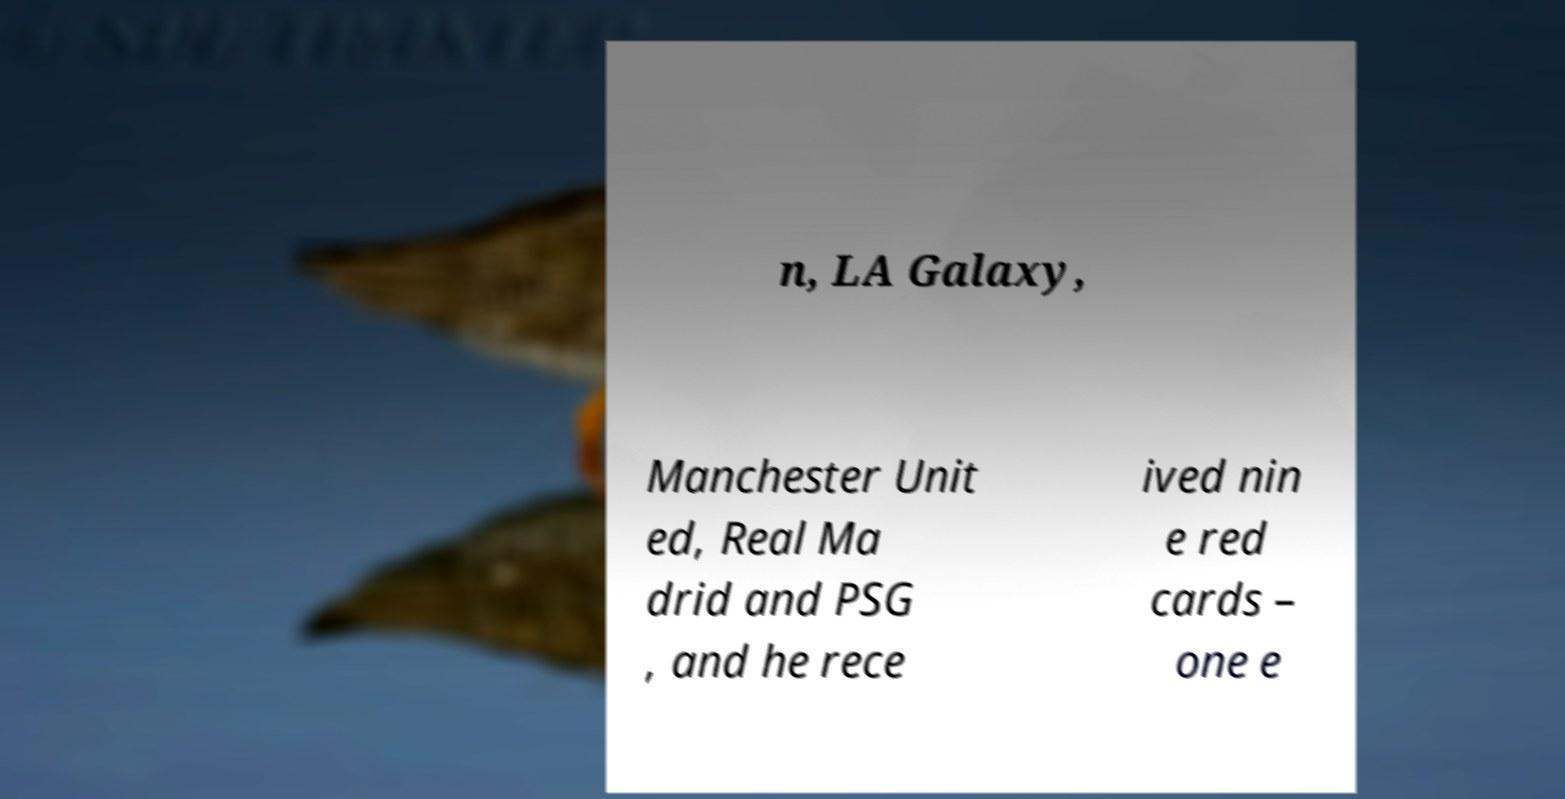Please identify and transcribe the text found in this image. n, LA Galaxy, Manchester Unit ed, Real Ma drid and PSG , and he rece ived nin e red cards – one e 